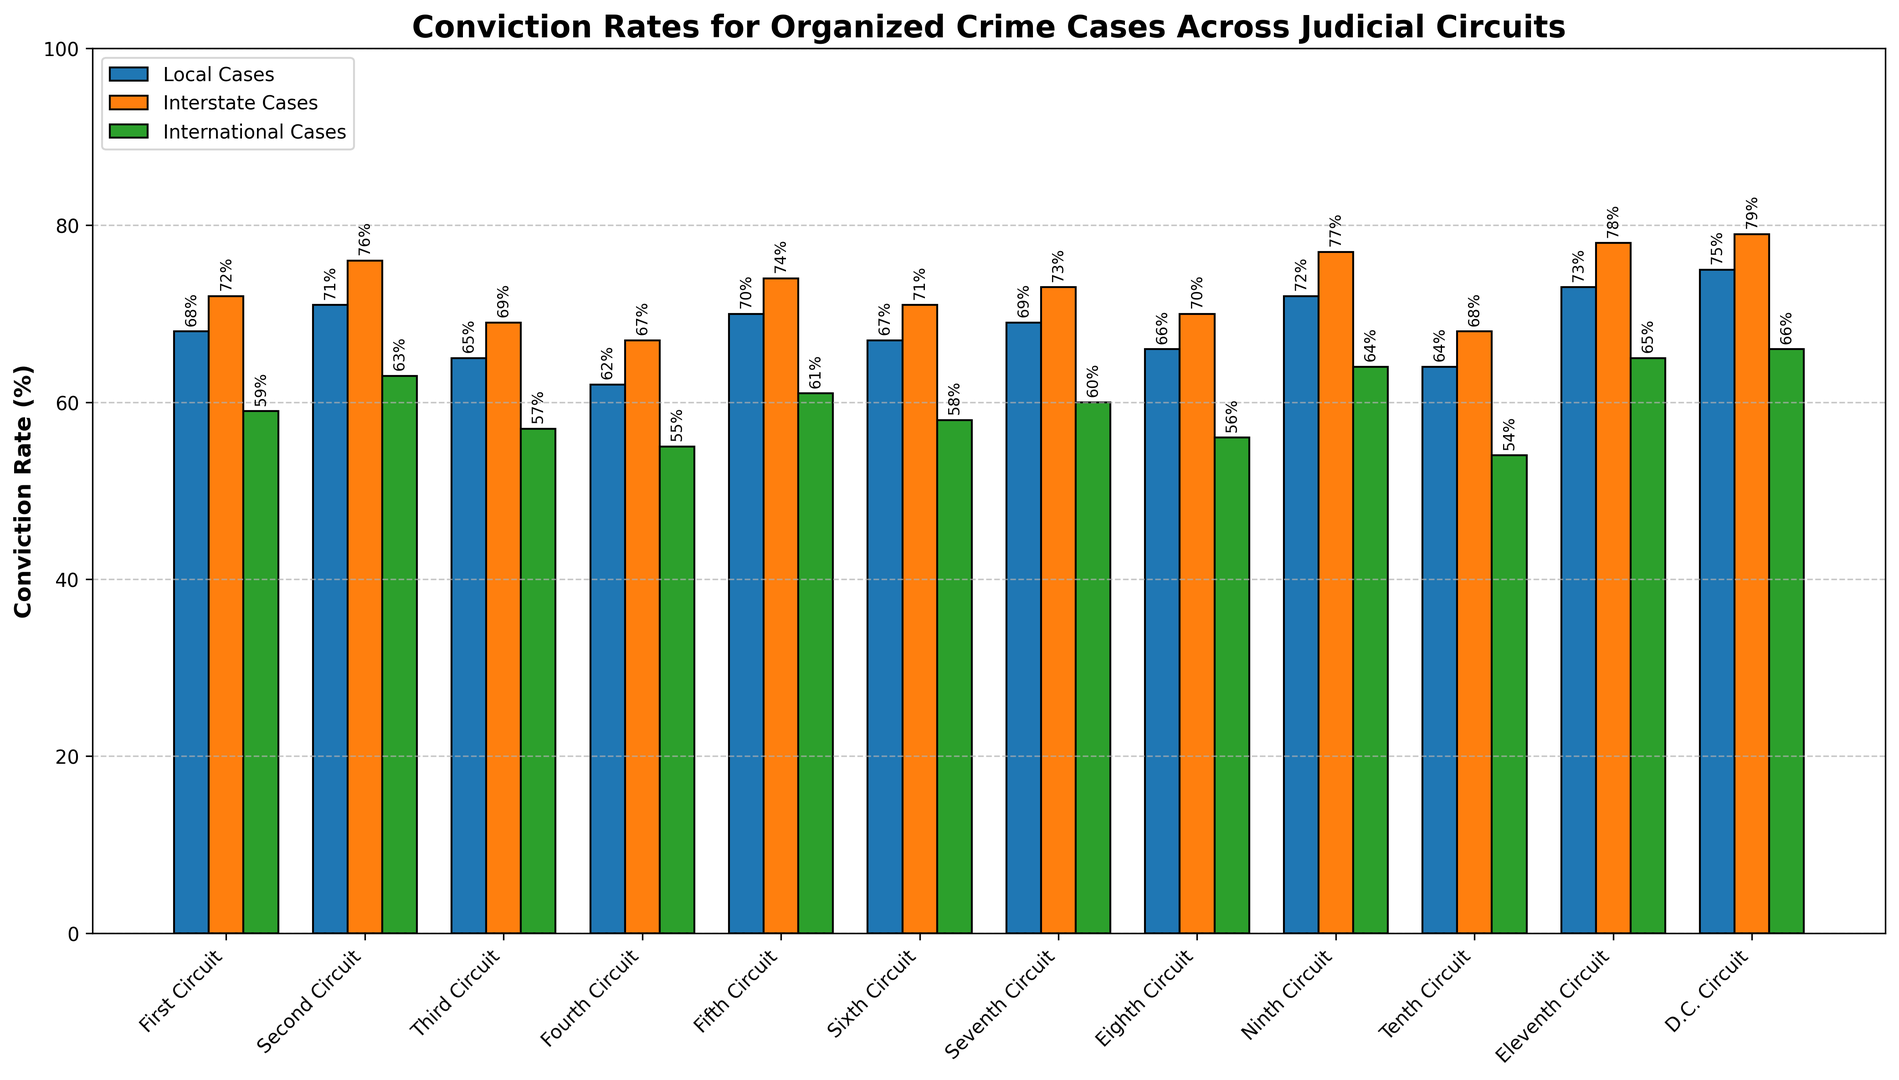Which judicial circuit has the highest conviction rate for international cases? The highest conviction rate bar in the green color, representing international cases, appears tallest for the D.C. Circuit compared to other circuits.
Answer: D.C. Circuit Which is greater, the conviction rate for local cases in the First Circuit or the conviction rate for international cases in the Seventh Circuit? The bar for local cases (blue) in the First Circuit is 68, while the bar for international cases (green) in the Seventh Circuit is 60. Since 68 is greater than 60, the First Circuit has a higher rate for local cases.
Answer: Local cases in the First Circuit What is the total conviction rate of international cases in the D.C. Circuit and Ninth Circuit? The international case conviction rates are 66 for the D.C. Circuit and 64 for the Ninth Circuit. Adding these together, 66 + 64 = 130.
Answer: 130 How many circuits have international case conviction rates above 60%? Circuits with conviction rates above 60 for international cases (green bars) are the Second Circuit, Fifth Circuit, Ninth Circuit, Eleventh Circuit, and D.C. Circuit. Counting them, there are 5 circuits.
Answer: 5 In which circuits is the conviction rate for interstate cases exactly 70%? Checking the orange bars for a height corresponding to 70 for interstate cases, we find that the Sixth and Eighth Circuits have a conviction rate of 70.
Answer: Sixth and Eighth Circuits In the Second Circuit, what is the difference between the conviction rates of local and interstate cases? The conviction rates in the Second Circuit are 71 for local cases and 76 for interstate cases. The difference is 76 - 71 = 5.
Answer: 5 Which circuit has the lowest overall conviction rate for each case type combined? Summing up the conviction rates for local, interstate, and international cases in each circuit and comparing them, we find the total for the Fourth Circuit is the lowest: 62 + 67 + 55 = 184.
Answer: Fourth Circuit What is the average conviction rate for international cases across all circuits? The international case conviction rates across all circuits are [59, 63, 57, 55, 61, 58, 60, 56, 64, 54, 65, 66]. Adding these together gives 718. Dividing by the number of circuits (12), the average is 718 / 12 ≈ 59.8.
Answer: 59.8 What is the ratio of local to interstate conviction rates in the Eleventh Circuit? Local case conviction rate is 73 and interstate case conviction rate is 78 in the Eleventh Circuit. The ratio is 73/78, which simplifies approximately to 0.94.
Answer: 0.94 Which circuit has the smallest difference between the conviction rates of local and international cases? Calculating the differences for each circuit, the smallest difference is found in the Ninth Circuit where local cases are 72 and international cases are 64, so the difference is 8.
Answer: Ninth Circuit 